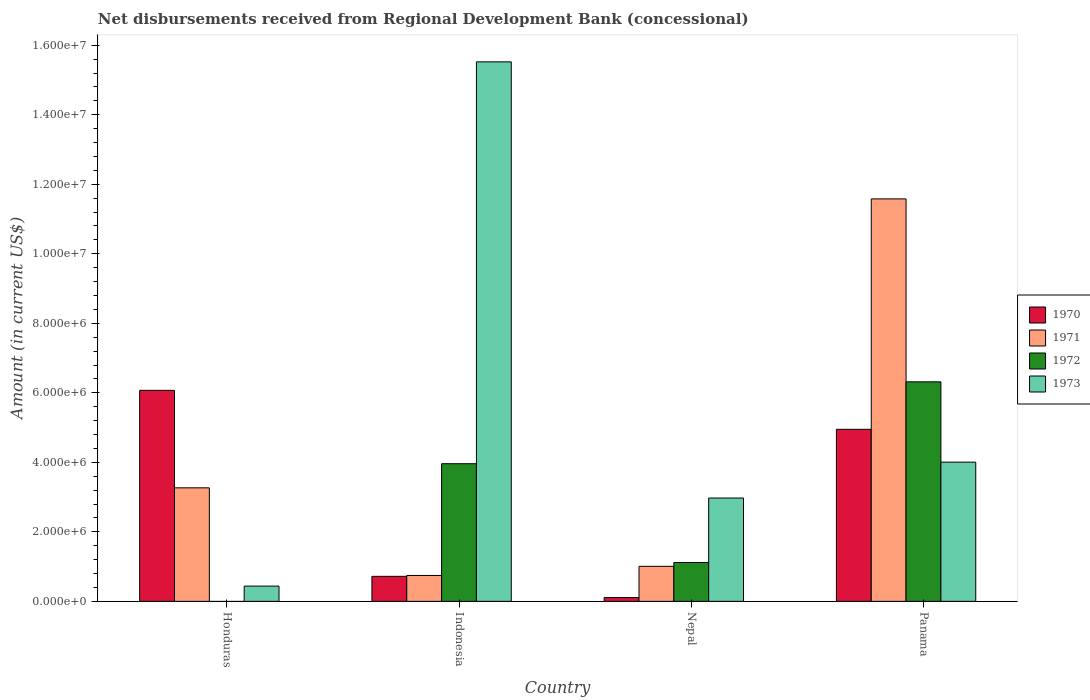How many different coloured bars are there?
Offer a very short reply. 4. How many groups of bars are there?
Make the answer very short. 4. How many bars are there on the 2nd tick from the left?
Offer a very short reply. 4. What is the label of the 1st group of bars from the left?
Your response must be concise. Honduras. What is the amount of disbursements received from Regional Development Bank in 1971 in Panama?
Offer a terse response. 1.16e+07. Across all countries, what is the maximum amount of disbursements received from Regional Development Bank in 1972?
Provide a succinct answer. 6.32e+06. Across all countries, what is the minimum amount of disbursements received from Regional Development Bank in 1971?
Ensure brevity in your answer.  7.45e+05. In which country was the amount of disbursements received from Regional Development Bank in 1972 maximum?
Ensure brevity in your answer.  Panama. What is the total amount of disbursements received from Regional Development Bank in 1970 in the graph?
Your response must be concise. 1.18e+07. What is the difference between the amount of disbursements received from Regional Development Bank in 1971 in Indonesia and that in Nepal?
Give a very brief answer. -2.63e+05. What is the difference between the amount of disbursements received from Regional Development Bank in 1971 in Indonesia and the amount of disbursements received from Regional Development Bank in 1972 in Nepal?
Keep it short and to the point. -3.73e+05. What is the average amount of disbursements received from Regional Development Bank in 1973 per country?
Your answer should be very brief. 5.73e+06. What is the difference between the amount of disbursements received from Regional Development Bank of/in 1971 and amount of disbursements received from Regional Development Bank of/in 1972 in Indonesia?
Give a very brief answer. -3.22e+06. In how many countries, is the amount of disbursements received from Regional Development Bank in 1970 greater than 14000000 US$?
Offer a terse response. 0. What is the ratio of the amount of disbursements received from Regional Development Bank in 1971 in Honduras to that in Panama?
Keep it short and to the point. 0.28. What is the difference between the highest and the second highest amount of disbursements received from Regional Development Bank in 1973?
Offer a very short reply. 1.25e+07. What is the difference between the highest and the lowest amount of disbursements received from Regional Development Bank in 1973?
Keep it short and to the point. 1.51e+07. In how many countries, is the amount of disbursements received from Regional Development Bank in 1973 greater than the average amount of disbursements received from Regional Development Bank in 1973 taken over all countries?
Offer a terse response. 1. Is it the case that in every country, the sum of the amount of disbursements received from Regional Development Bank in 1970 and amount of disbursements received from Regional Development Bank in 1972 is greater than the sum of amount of disbursements received from Regional Development Bank in 1973 and amount of disbursements received from Regional Development Bank in 1971?
Give a very brief answer. No. Are all the bars in the graph horizontal?
Your answer should be very brief. No. How many countries are there in the graph?
Ensure brevity in your answer.  4. What is the difference between two consecutive major ticks on the Y-axis?
Your response must be concise. 2.00e+06. Are the values on the major ticks of Y-axis written in scientific E-notation?
Offer a very short reply. Yes. Does the graph contain grids?
Give a very brief answer. No. Where does the legend appear in the graph?
Offer a terse response. Center right. How many legend labels are there?
Make the answer very short. 4. What is the title of the graph?
Your response must be concise. Net disbursements received from Regional Development Bank (concessional). Does "1992" appear as one of the legend labels in the graph?
Make the answer very short. No. What is the label or title of the Y-axis?
Provide a short and direct response. Amount (in current US$). What is the Amount (in current US$) in 1970 in Honduras?
Offer a terse response. 6.07e+06. What is the Amount (in current US$) in 1971 in Honduras?
Offer a terse response. 3.27e+06. What is the Amount (in current US$) in 1973 in Honduras?
Provide a short and direct response. 4.39e+05. What is the Amount (in current US$) in 1970 in Indonesia?
Provide a succinct answer. 7.20e+05. What is the Amount (in current US$) in 1971 in Indonesia?
Your response must be concise. 7.45e+05. What is the Amount (in current US$) in 1972 in Indonesia?
Provide a short and direct response. 3.96e+06. What is the Amount (in current US$) in 1973 in Indonesia?
Your answer should be very brief. 1.55e+07. What is the Amount (in current US$) of 1970 in Nepal?
Provide a succinct answer. 1.09e+05. What is the Amount (in current US$) of 1971 in Nepal?
Your answer should be compact. 1.01e+06. What is the Amount (in current US$) in 1972 in Nepal?
Provide a short and direct response. 1.12e+06. What is the Amount (in current US$) in 1973 in Nepal?
Keep it short and to the point. 2.97e+06. What is the Amount (in current US$) in 1970 in Panama?
Make the answer very short. 4.95e+06. What is the Amount (in current US$) in 1971 in Panama?
Provide a short and direct response. 1.16e+07. What is the Amount (in current US$) in 1972 in Panama?
Your response must be concise. 6.32e+06. What is the Amount (in current US$) of 1973 in Panama?
Give a very brief answer. 4.00e+06. Across all countries, what is the maximum Amount (in current US$) of 1970?
Offer a terse response. 6.07e+06. Across all countries, what is the maximum Amount (in current US$) in 1971?
Your answer should be very brief. 1.16e+07. Across all countries, what is the maximum Amount (in current US$) in 1972?
Provide a short and direct response. 6.32e+06. Across all countries, what is the maximum Amount (in current US$) of 1973?
Make the answer very short. 1.55e+07. Across all countries, what is the minimum Amount (in current US$) in 1970?
Keep it short and to the point. 1.09e+05. Across all countries, what is the minimum Amount (in current US$) of 1971?
Make the answer very short. 7.45e+05. Across all countries, what is the minimum Amount (in current US$) of 1973?
Ensure brevity in your answer.  4.39e+05. What is the total Amount (in current US$) in 1970 in the graph?
Ensure brevity in your answer.  1.18e+07. What is the total Amount (in current US$) in 1971 in the graph?
Give a very brief answer. 1.66e+07. What is the total Amount (in current US$) in 1972 in the graph?
Ensure brevity in your answer.  1.14e+07. What is the total Amount (in current US$) of 1973 in the graph?
Keep it short and to the point. 2.29e+07. What is the difference between the Amount (in current US$) of 1970 in Honduras and that in Indonesia?
Make the answer very short. 5.35e+06. What is the difference between the Amount (in current US$) in 1971 in Honduras and that in Indonesia?
Offer a very short reply. 2.52e+06. What is the difference between the Amount (in current US$) in 1973 in Honduras and that in Indonesia?
Your answer should be compact. -1.51e+07. What is the difference between the Amount (in current US$) of 1970 in Honduras and that in Nepal?
Your answer should be compact. 5.96e+06. What is the difference between the Amount (in current US$) in 1971 in Honduras and that in Nepal?
Your answer should be very brief. 2.26e+06. What is the difference between the Amount (in current US$) of 1973 in Honduras and that in Nepal?
Your answer should be very brief. -2.53e+06. What is the difference between the Amount (in current US$) in 1970 in Honduras and that in Panama?
Provide a short and direct response. 1.12e+06. What is the difference between the Amount (in current US$) of 1971 in Honduras and that in Panama?
Offer a terse response. -8.31e+06. What is the difference between the Amount (in current US$) of 1973 in Honduras and that in Panama?
Your response must be concise. -3.57e+06. What is the difference between the Amount (in current US$) of 1970 in Indonesia and that in Nepal?
Provide a short and direct response. 6.11e+05. What is the difference between the Amount (in current US$) of 1971 in Indonesia and that in Nepal?
Keep it short and to the point. -2.63e+05. What is the difference between the Amount (in current US$) of 1972 in Indonesia and that in Nepal?
Your response must be concise. 2.84e+06. What is the difference between the Amount (in current US$) of 1973 in Indonesia and that in Nepal?
Offer a very short reply. 1.25e+07. What is the difference between the Amount (in current US$) in 1970 in Indonesia and that in Panama?
Offer a terse response. -4.23e+06. What is the difference between the Amount (in current US$) in 1971 in Indonesia and that in Panama?
Provide a succinct answer. -1.08e+07. What is the difference between the Amount (in current US$) in 1972 in Indonesia and that in Panama?
Keep it short and to the point. -2.36e+06. What is the difference between the Amount (in current US$) in 1973 in Indonesia and that in Panama?
Your answer should be very brief. 1.15e+07. What is the difference between the Amount (in current US$) of 1970 in Nepal and that in Panama?
Give a very brief answer. -4.84e+06. What is the difference between the Amount (in current US$) of 1971 in Nepal and that in Panama?
Provide a short and direct response. -1.06e+07. What is the difference between the Amount (in current US$) of 1972 in Nepal and that in Panama?
Give a very brief answer. -5.20e+06. What is the difference between the Amount (in current US$) of 1973 in Nepal and that in Panama?
Provide a short and direct response. -1.03e+06. What is the difference between the Amount (in current US$) of 1970 in Honduras and the Amount (in current US$) of 1971 in Indonesia?
Your response must be concise. 5.33e+06. What is the difference between the Amount (in current US$) of 1970 in Honduras and the Amount (in current US$) of 1972 in Indonesia?
Your response must be concise. 2.11e+06. What is the difference between the Amount (in current US$) in 1970 in Honduras and the Amount (in current US$) in 1973 in Indonesia?
Provide a succinct answer. -9.45e+06. What is the difference between the Amount (in current US$) of 1971 in Honduras and the Amount (in current US$) of 1972 in Indonesia?
Your answer should be very brief. -6.94e+05. What is the difference between the Amount (in current US$) of 1971 in Honduras and the Amount (in current US$) of 1973 in Indonesia?
Your response must be concise. -1.23e+07. What is the difference between the Amount (in current US$) of 1970 in Honduras and the Amount (in current US$) of 1971 in Nepal?
Offer a terse response. 5.06e+06. What is the difference between the Amount (in current US$) of 1970 in Honduras and the Amount (in current US$) of 1972 in Nepal?
Make the answer very short. 4.95e+06. What is the difference between the Amount (in current US$) in 1970 in Honduras and the Amount (in current US$) in 1973 in Nepal?
Make the answer very short. 3.10e+06. What is the difference between the Amount (in current US$) of 1971 in Honduras and the Amount (in current US$) of 1972 in Nepal?
Give a very brief answer. 2.15e+06. What is the difference between the Amount (in current US$) in 1971 in Honduras and the Amount (in current US$) in 1973 in Nepal?
Provide a succinct answer. 2.93e+05. What is the difference between the Amount (in current US$) in 1970 in Honduras and the Amount (in current US$) in 1971 in Panama?
Ensure brevity in your answer.  -5.51e+06. What is the difference between the Amount (in current US$) of 1970 in Honduras and the Amount (in current US$) of 1972 in Panama?
Offer a terse response. -2.45e+05. What is the difference between the Amount (in current US$) in 1970 in Honduras and the Amount (in current US$) in 1973 in Panama?
Provide a succinct answer. 2.07e+06. What is the difference between the Amount (in current US$) in 1971 in Honduras and the Amount (in current US$) in 1972 in Panama?
Your answer should be very brief. -3.05e+06. What is the difference between the Amount (in current US$) of 1971 in Honduras and the Amount (in current US$) of 1973 in Panama?
Ensure brevity in your answer.  -7.39e+05. What is the difference between the Amount (in current US$) in 1970 in Indonesia and the Amount (in current US$) in 1971 in Nepal?
Keep it short and to the point. -2.88e+05. What is the difference between the Amount (in current US$) of 1970 in Indonesia and the Amount (in current US$) of 1972 in Nepal?
Provide a short and direct response. -3.98e+05. What is the difference between the Amount (in current US$) in 1970 in Indonesia and the Amount (in current US$) in 1973 in Nepal?
Offer a very short reply. -2.25e+06. What is the difference between the Amount (in current US$) of 1971 in Indonesia and the Amount (in current US$) of 1972 in Nepal?
Make the answer very short. -3.73e+05. What is the difference between the Amount (in current US$) in 1971 in Indonesia and the Amount (in current US$) in 1973 in Nepal?
Provide a short and direct response. -2.23e+06. What is the difference between the Amount (in current US$) in 1972 in Indonesia and the Amount (in current US$) in 1973 in Nepal?
Offer a terse response. 9.87e+05. What is the difference between the Amount (in current US$) in 1970 in Indonesia and the Amount (in current US$) in 1971 in Panama?
Your response must be concise. -1.09e+07. What is the difference between the Amount (in current US$) in 1970 in Indonesia and the Amount (in current US$) in 1972 in Panama?
Make the answer very short. -5.60e+06. What is the difference between the Amount (in current US$) in 1970 in Indonesia and the Amount (in current US$) in 1973 in Panama?
Ensure brevity in your answer.  -3.28e+06. What is the difference between the Amount (in current US$) of 1971 in Indonesia and the Amount (in current US$) of 1972 in Panama?
Give a very brief answer. -5.57e+06. What is the difference between the Amount (in current US$) of 1971 in Indonesia and the Amount (in current US$) of 1973 in Panama?
Keep it short and to the point. -3.26e+06. What is the difference between the Amount (in current US$) of 1972 in Indonesia and the Amount (in current US$) of 1973 in Panama?
Offer a very short reply. -4.50e+04. What is the difference between the Amount (in current US$) in 1970 in Nepal and the Amount (in current US$) in 1971 in Panama?
Provide a short and direct response. -1.15e+07. What is the difference between the Amount (in current US$) of 1970 in Nepal and the Amount (in current US$) of 1972 in Panama?
Your answer should be compact. -6.21e+06. What is the difference between the Amount (in current US$) of 1970 in Nepal and the Amount (in current US$) of 1973 in Panama?
Provide a short and direct response. -3.90e+06. What is the difference between the Amount (in current US$) in 1971 in Nepal and the Amount (in current US$) in 1972 in Panama?
Your answer should be compact. -5.31e+06. What is the difference between the Amount (in current US$) of 1971 in Nepal and the Amount (in current US$) of 1973 in Panama?
Ensure brevity in your answer.  -3.00e+06. What is the difference between the Amount (in current US$) in 1972 in Nepal and the Amount (in current US$) in 1973 in Panama?
Offer a very short reply. -2.89e+06. What is the average Amount (in current US$) of 1970 per country?
Provide a short and direct response. 2.96e+06. What is the average Amount (in current US$) of 1971 per country?
Your answer should be very brief. 4.15e+06. What is the average Amount (in current US$) in 1972 per country?
Ensure brevity in your answer.  2.85e+06. What is the average Amount (in current US$) of 1973 per country?
Provide a short and direct response. 5.73e+06. What is the difference between the Amount (in current US$) of 1970 and Amount (in current US$) of 1971 in Honduras?
Offer a very short reply. 2.80e+06. What is the difference between the Amount (in current US$) of 1970 and Amount (in current US$) of 1973 in Honduras?
Your answer should be compact. 5.63e+06. What is the difference between the Amount (in current US$) of 1971 and Amount (in current US$) of 1973 in Honduras?
Ensure brevity in your answer.  2.83e+06. What is the difference between the Amount (in current US$) of 1970 and Amount (in current US$) of 1971 in Indonesia?
Your response must be concise. -2.50e+04. What is the difference between the Amount (in current US$) in 1970 and Amount (in current US$) in 1972 in Indonesia?
Provide a short and direct response. -3.24e+06. What is the difference between the Amount (in current US$) of 1970 and Amount (in current US$) of 1973 in Indonesia?
Your response must be concise. -1.48e+07. What is the difference between the Amount (in current US$) of 1971 and Amount (in current US$) of 1972 in Indonesia?
Keep it short and to the point. -3.22e+06. What is the difference between the Amount (in current US$) of 1971 and Amount (in current US$) of 1973 in Indonesia?
Give a very brief answer. -1.48e+07. What is the difference between the Amount (in current US$) in 1972 and Amount (in current US$) in 1973 in Indonesia?
Make the answer very short. -1.16e+07. What is the difference between the Amount (in current US$) in 1970 and Amount (in current US$) in 1971 in Nepal?
Provide a succinct answer. -8.99e+05. What is the difference between the Amount (in current US$) of 1970 and Amount (in current US$) of 1972 in Nepal?
Your answer should be very brief. -1.01e+06. What is the difference between the Amount (in current US$) in 1970 and Amount (in current US$) in 1973 in Nepal?
Give a very brief answer. -2.86e+06. What is the difference between the Amount (in current US$) of 1971 and Amount (in current US$) of 1972 in Nepal?
Offer a terse response. -1.10e+05. What is the difference between the Amount (in current US$) in 1971 and Amount (in current US$) in 1973 in Nepal?
Ensure brevity in your answer.  -1.96e+06. What is the difference between the Amount (in current US$) of 1972 and Amount (in current US$) of 1973 in Nepal?
Offer a very short reply. -1.86e+06. What is the difference between the Amount (in current US$) in 1970 and Amount (in current US$) in 1971 in Panama?
Provide a short and direct response. -6.63e+06. What is the difference between the Amount (in current US$) of 1970 and Amount (in current US$) of 1972 in Panama?
Your response must be concise. -1.37e+06. What is the difference between the Amount (in current US$) of 1970 and Amount (in current US$) of 1973 in Panama?
Ensure brevity in your answer.  9.45e+05. What is the difference between the Amount (in current US$) of 1971 and Amount (in current US$) of 1972 in Panama?
Your answer should be very brief. 5.26e+06. What is the difference between the Amount (in current US$) in 1971 and Amount (in current US$) in 1973 in Panama?
Your answer should be compact. 7.57e+06. What is the difference between the Amount (in current US$) of 1972 and Amount (in current US$) of 1973 in Panama?
Your answer should be compact. 2.31e+06. What is the ratio of the Amount (in current US$) in 1970 in Honduras to that in Indonesia?
Offer a terse response. 8.43. What is the ratio of the Amount (in current US$) in 1971 in Honduras to that in Indonesia?
Offer a terse response. 4.38. What is the ratio of the Amount (in current US$) in 1973 in Honduras to that in Indonesia?
Offer a terse response. 0.03. What is the ratio of the Amount (in current US$) of 1970 in Honduras to that in Nepal?
Offer a terse response. 55.7. What is the ratio of the Amount (in current US$) of 1971 in Honduras to that in Nepal?
Offer a terse response. 3.24. What is the ratio of the Amount (in current US$) of 1973 in Honduras to that in Nepal?
Provide a short and direct response. 0.15. What is the ratio of the Amount (in current US$) of 1970 in Honduras to that in Panama?
Give a very brief answer. 1.23. What is the ratio of the Amount (in current US$) in 1971 in Honduras to that in Panama?
Your response must be concise. 0.28. What is the ratio of the Amount (in current US$) in 1973 in Honduras to that in Panama?
Ensure brevity in your answer.  0.11. What is the ratio of the Amount (in current US$) in 1970 in Indonesia to that in Nepal?
Give a very brief answer. 6.61. What is the ratio of the Amount (in current US$) in 1971 in Indonesia to that in Nepal?
Provide a succinct answer. 0.74. What is the ratio of the Amount (in current US$) of 1972 in Indonesia to that in Nepal?
Your response must be concise. 3.54. What is the ratio of the Amount (in current US$) of 1973 in Indonesia to that in Nepal?
Your response must be concise. 5.22. What is the ratio of the Amount (in current US$) of 1970 in Indonesia to that in Panama?
Make the answer very short. 0.15. What is the ratio of the Amount (in current US$) of 1971 in Indonesia to that in Panama?
Your answer should be very brief. 0.06. What is the ratio of the Amount (in current US$) of 1972 in Indonesia to that in Panama?
Your answer should be very brief. 0.63. What is the ratio of the Amount (in current US$) in 1973 in Indonesia to that in Panama?
Ensure brevity in your answer.  3.88. What is the ratio of the Amount (in current US$) of 1970 in Nepal to that in Panama?
Provide a short and direct response. 0.02. What is the ratio of the Amount (in current US$) of 1971 in Nepal to that in Panama?
Offer a very short reply. 0.09. What is the ratio of the Amount (in current US$) in 1972 in Nepal to that in Panama?
Keep it short and to the point. 0.18. What is the ratio of the Amount (in current US$) in 1973 in Nepal to that in Panama?
Keep it short and to the point. 0.74. What is the difference between the highest and the second highest Amount (in current US$) of 1970?
Make the answer very short. 1.12e+06. What is the difference between the highest and the second highest Amount (in current US$) in 1971?
Keep it short and to the point. 8.31e+06. What is the difference between the highest and the second highest Amount (in current US$) in 1972?
Offer a terse response. 2.36e+06. What is the difference between the highest and the second highest Amount (in current US$) of 1973?
Give a very brief answer. 1.15e+07. What is the difference between the highest and the lowest Amount (in current US$) in 1970?
Offer a very short reply. 5.96e+06. What is the difference between the highest and the lowest Amount (in current US$) in 1971?
Your answer should be very brief. 1.08e+07. What is the difference between the highest and the lowest Amount (in current US$) of 1972?
Offer a terse response. 6.32e+06. What is the difference between the highest and the lowest Amount (in current US$) in 1973?
Offer a terse response. 1.51e+07. 